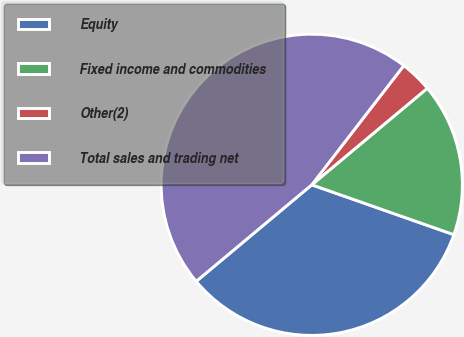Convert chart. <chart><loc_0><loc_0><loc_500><loc_500><pie_chart><fcel>Equity<fcel>Fixed income and commodities<fcel>Other(2)<fcel>Total sales and trading net<nl><fcel>33.55%<fcel>16.45%<fcel>3.46%<fcel>46.54%<nl></chart> 